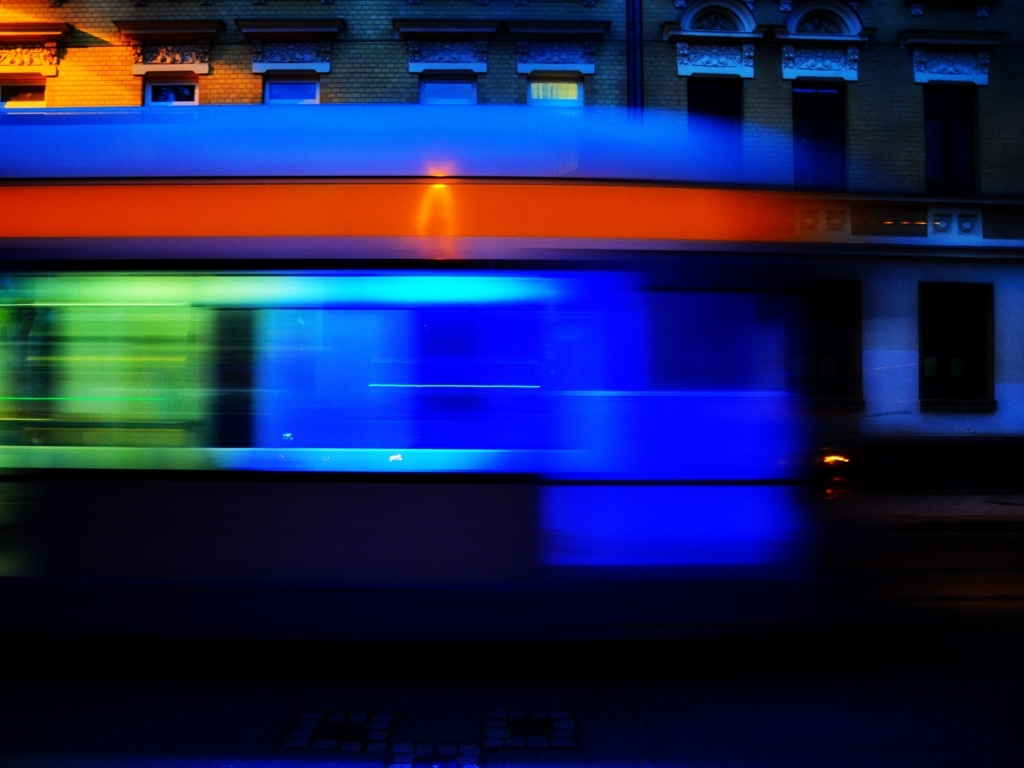Could you describe the technical aspects of how this image might have been captured? Certainly. To capture the motion blur of the bus, the photographer likely used a slower shutter speed, allowing the sensor to record the moving bus over a period of time. They may have used a tripod or steady surface to keep the camera still and ensure the stationary objects remained in focus. What could this image symbolize in a broader context? Beyond its visual appeal, the image could symbolize the relentless passage of time, the swift pace of urban life, or the transient nature of our daily travels. The stillness of the building might represent permanence in contrast to the ephemeral existence of the bus and its passengers. 